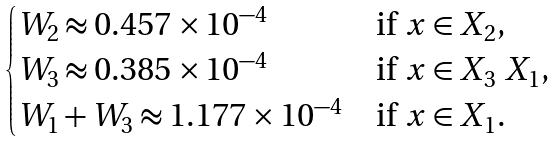Convert formula to latex. <formula><loc_0><loc_0><loc_500><loc_500>\begin{cases} W _ { 2 } \approx 0 . 4 5 7 \times 1 0 ^ { - 4 } & \text {if $x\in X_{2}$,} \\ W _ { 3 } \approx 0 . 3 8 5 \times 1 0 ^ { - 4 } & \text {if $x\in X_{3}\ X_{1}$,} \\ W _ { 1 } + W _ { 3 } \approx 1 . 1 7 7 \times 1 0 ^ { - 4 } & \text {if $x\in X_{1}$.} \end{cases}</formula> 